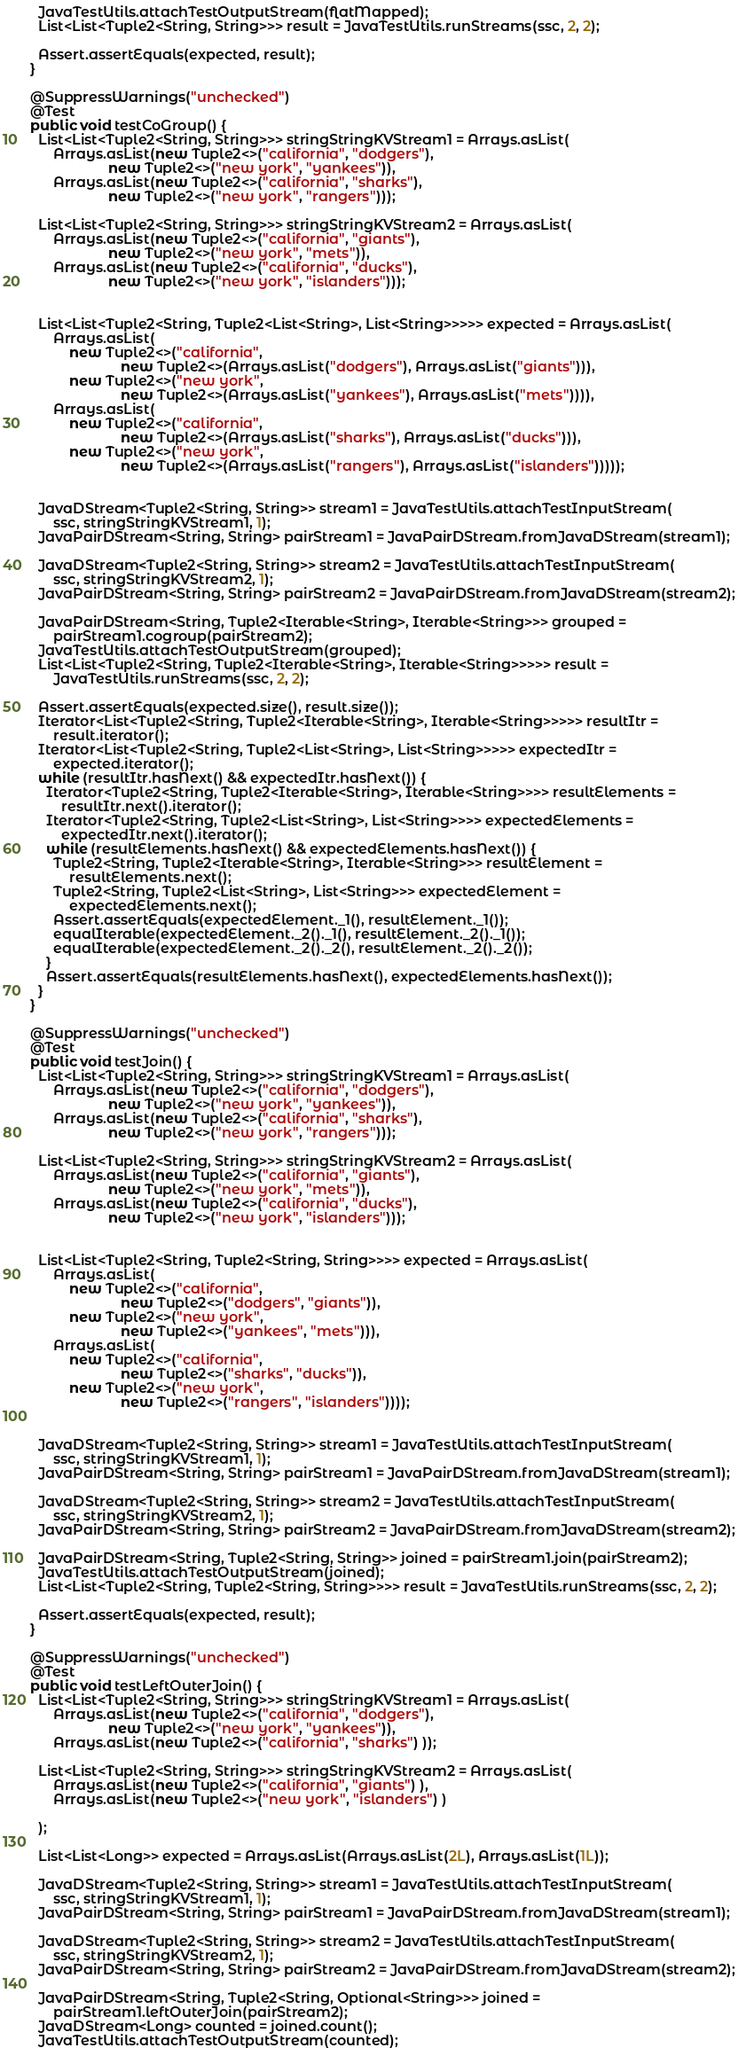<code> <loc_0><loc_0><loc_500><loc_500><_Java_>
    JavaTestUtils.attachTestOutputStream(flatMapped);
    List<List<Tuple2<String, String>>> result = JavaTestUtils.runStreams(ssc, 2, 2);

    Assert.assertEquals(expected, result);
  }

  @SuppressWarnings("unchecked")
  @Test
  public void testCoGroup() {
    List<List<Tuple2<String, String>>> stringStringKVStream1 = Arrays.asList(
        Arrays.asList(new Tuple2<>("california", "dodgers"),
                      new Tuple2<>("new york", "yankees")),
        Arrays.asList(new Tuple2<>("california", "sharks"),
                      new Tuple2<>("new york", "rangers")));

    List<List<Tuple2<String, String>>> stringStringKVStream2 = Arrays.asList(
        Arrays.asList(new Tuple2<>("california", "giants"),
                      new Tuple2<>("new york", "mets")),
        Arrays.asList(new Tuple2<>("california", "ducks"),
                      new Tuple2<>("new york", "islanders")));


    List<List<Tuple2<String, Tuple2<List<String>, List<String>>>>> expected = Arrays.asList(
        Arrays.asList(
            new Tuple2<>("california",
                         new Tuple2<>(Arrays.asList("dodgers"), Arrays.asList("giants"))),
            new Tuple2<>("new york",
                         new Tuple2<>(Arrays.asList("yankees"), Arrays.asList("mets")))),
        Arrays.asList(
            new Tuple2<>("california",
                         new Tuple2<>(Arrays.asList("sharks"), Arrays.asList("ducks"))),
            new Tuple2<>("new york",
                         new Tuple2<>(Arrays.asList("rangers"), Arrays.asList("islanders")))));


    JavaDStream<Tuple2<String, String>> stream1 = JavaTestUtils.attachTestInputStream(
        ssc, stringStringKVStream1, 1);
    JavaPairDStream<String, String> pairStream1 = JavaPairDStream.fromJavaDStream(stream1);

    JavaDStream<Tuple2<String, String>> stream2 = JavaTestUtils.attachTestInputStream(
        ssc, stringStringKVStream2, 1);
    JavaPairDStream<String, String> pairStream2 = JavaPairDStream.fromJavaDStream(stream2);

    JavaPairDStream<String, Tuple2<Iterable<String>, Iterable<String>>> grouped =
        pairStream1.cogroup(pairStream2);
    JavaTestUtils.attachTestOutputStream(grouped);
    List<List<Tuple2<String, Tuple2<Iterable<String>, Iterable<String>>>>> result =
        JavaTestUtils.runStreams(ssc, 2, 2);

    Assert.assertEquals(expected.size(), result.size());
    Iterator<List<Tuple2<String, Tuple2<Iterable<String>, Iterable<String>>>>> resultItr =
        result.iterator();
    Iterator<List<Tuple2<String, Tuple2<List<String>, List<String>>>>> expectedItr =
        expected.iterator();
    while (resultItr.hasNext() && expectedItr.hasNext()) {
      Iterator<Tuple2<String, Tuple2<Iterable<String>, Iterable<String>>>> resultElements =
          resultItr.next().iterator();
      Iterator<Tuple2<String, Tuple2<List<String>, List<String>>>> expectedElements =
          expectedItr.next().iterator();
      while (resultElements.hasNext() && expectedElements.hasNext()) {
        Tuple2<String, Tuple2<Iterable<String>, Iterable<String>>> resultElement =
            resultElements.next();
        Tuple2<String, Tuple2<List<String>, List<String>>> expectedElement =
            expectedElements.next();
        Assert.assertEquals(expectedElement._1(), resultElement._1());
        equalIterable(expectedElement._2()._1(), resultElement._2()._1());
        equalIterable(expectedElement._2()._2(), resultElement._2()._2());
      }
      Assert.assertEquals(resultElements.hasNext(), expectedElements.hasNext());
    }
  }

  @SuppressWarnings("unchecked")
  @Test
  public void testJoin() {
    List<List<Tuple2<String, String>>> stringStringKVStream1 = Arrays.asList(
        Arrays.asList(new Tuple2<>("california", "dodgers"),
                      new Tuple2<>("new york", "yankees")),
        Arrays.asList(new Tuple2<>("california", "sharks"),
                      new Tuple2<>("new york", "rangers")));

    List<List<Tuple2<String, String>>> stringStringKVStream2 = Arrays.asList(
        Arrays.asList(new Tuple2<>("california", "giants"),
                      new Tuple2<>("new york", "mets")),
        Arrays.asList(new Tuple2<>("california", "ducks"),
                      new Tuple2<>("new york", "islanders")));


    List<List<Tuple2<String, Tuple2<String, String>>>> expected = Arrays.asList(
        Arrays.asList(
            new Tuple2<>("california",
                         new Tuple2<>("dodgers", "giants")),
            new Tuple2<>("new york",
                         new Tuple2<>("yankees", "mets"))),
        Arrays.asList(
            new Tuple2<>("california",
                         new Tuple2<>("sharks", "ducks")),
            new Tuple2<>("new york",
                         new Tuple2<>("rangers", "islanders"))));


    JavaDStream<Tuple2<String, String>> stream1 = JavaTestUtils.attachTestInputStream(
        ssc, stringStringKVStream1, 1);
    JavaPairDStream<String, String> pairStream1 = JavaPairDStream.fromJavaDStream(stream1);

    JavaDStream<Tuple2<String, String>> stream2 = JavaTestUtils.attachTestInputStream(
        ssc, stringStringKVStream2, 1);
    JavaPairDStream<String, String> pairStream2 = JavaPairDStream.fromJavaDStream(stream2);

    JavaPairDStream<String, Tuple2<String, String>> joined = pairStream1.join(pairStream2);
    JavaTestUtils.attachTestOutputStream(joined);
    List<List<Tuple2<String, Tuple2<String, String>>>> result = JavaTestUtils.runStreams(ssc, 2, 2);

    Assert.assertEquals(expected, result);
  }

  @SuppressWarnings("unchecked")
  @Test
  public void testLeftOuterJoin() {
    List<List<Tuple2<String, String>>> stringStringKVStream1 = Arrays.asList(
        Arrays.asList(new Tuple2<>("california", "dodgers"),
                      new Tuple2<>("new york", "yankees")),
        Arrays.asList(new Tuple2<>("california", "sharks") ));

    List<List<Tuple2<String, String>>> stringStringKVStream2 = Arrays.asList(
        Arrays.asList(new Tuple2<>("california", "giants") ),
        Arrays.asList(new Tuple2<>("new york", "islanders") )

    );

    List<List<Long>> expected = Arrays.asList(Arrays.asList(2L), Arrays.asList(1L));

    JavaDStream<Tuple2<String, String>> stream1 = JavaTestUtils.attachTestInputStream(
        ssc, stringStringKVStream1, 1);
    JavaPairDStream<String, String> pairStream1 = JavaPairDStream.fromJavaDStream(stream1);

    JavaDStream<Tuple2<String, String>> stream2 = JavaTestUtils.attachTestInputStream(
        ssc, stringStringKVStream2, 1);
    JavaPairDStream<String, String> pairStream2 = JavaPairDStream.fromJavaDStream(stream2);

    JavaPairDStream<String, Tuple2<String, Optional<String>>> joined =
        pairStream1.leftOuterJoin(pairStream2);
    JavaDStream<Long> counted = joined.count();
    JavaTestUtils.attachTestOutputStream(counted);</code> 